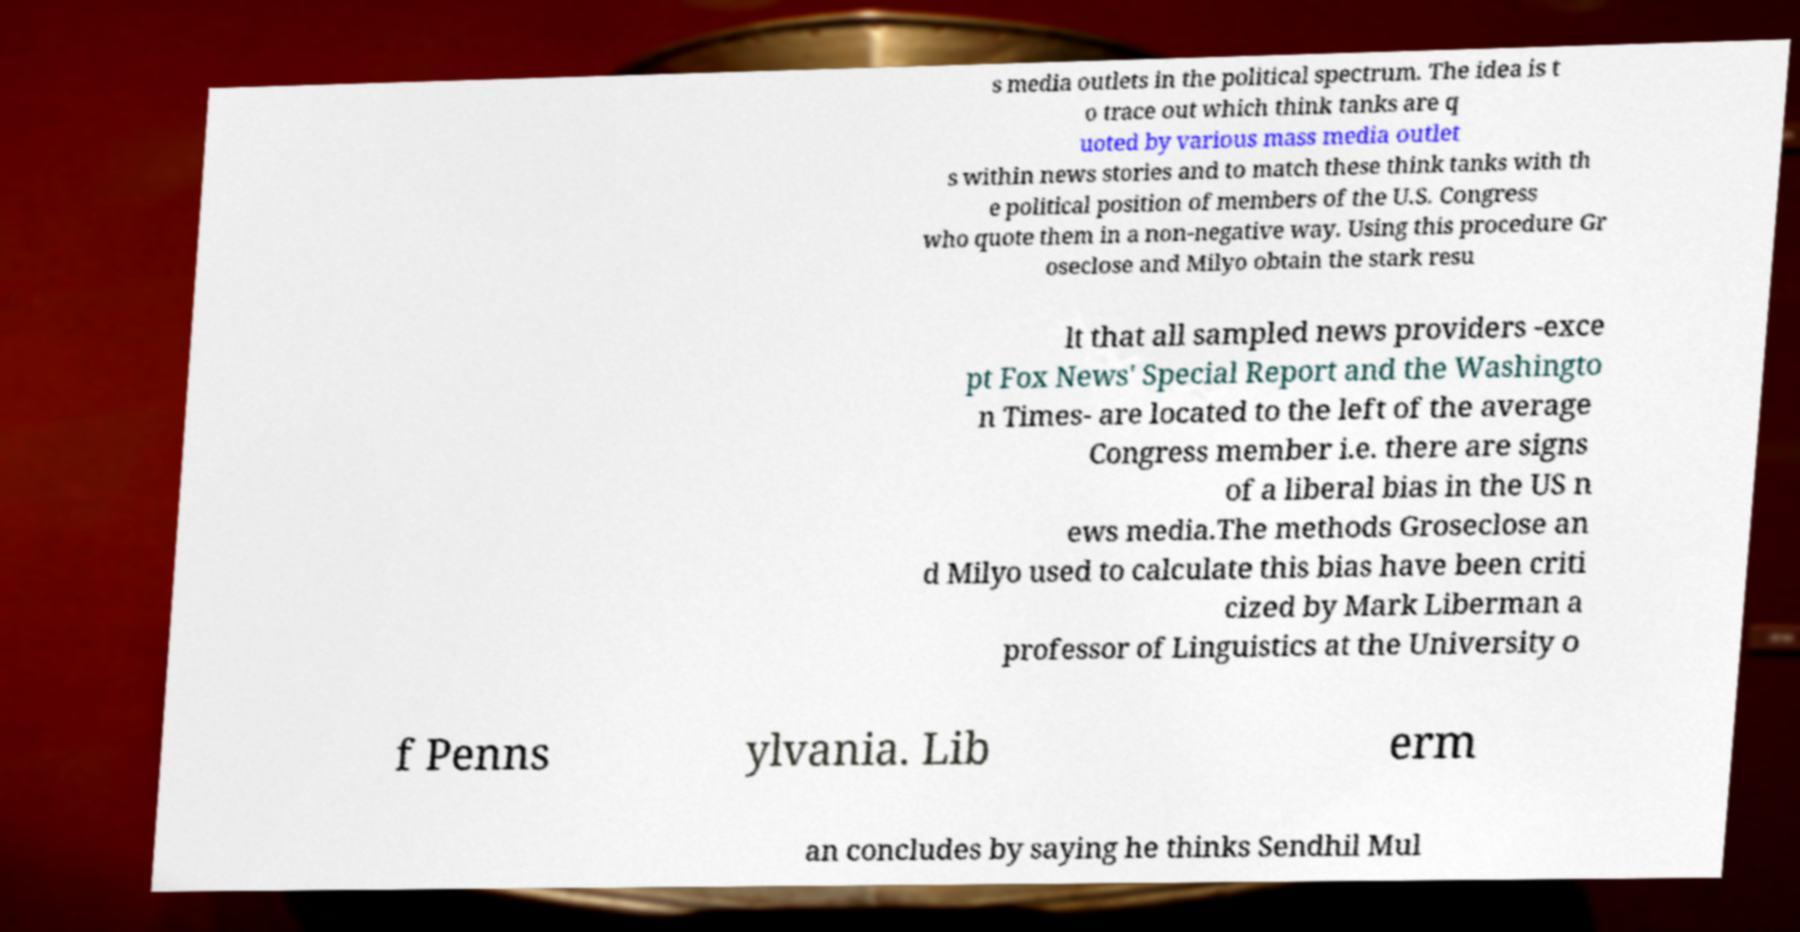There's text embedded in this image that I need extracted. Can you transcribe it verbatim? s media outlets in the political spectrum. The idea is t o trace out which think tanks are q uoted by various mass media outlet s within news stories and to match these think tanks with th e political position of members of the U.S. Congress who quote them in a non-negative way. Using this procedure Gr oseclose and Milyo obtain the stark resu lt that all sampled news providers -exce pt Fox News' Special Report and the Washingto n Times- are located to the left of the average Congress member i.e. there are signs of a liberal bias in the US n ews media.The methods Groseclose an d Milyo used to calculate this bias have been criti cized by Mark Liberman a professor of Linguistics at the University o f Penns ylvania. Lib erm an concludes by saying he thinks Sendhil Mul 